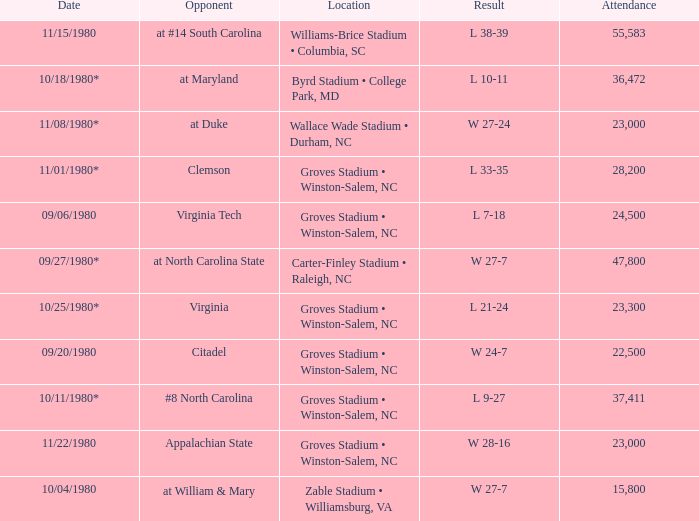How many people attended when Wake Forest played Virginia Tech? 24500.0. 